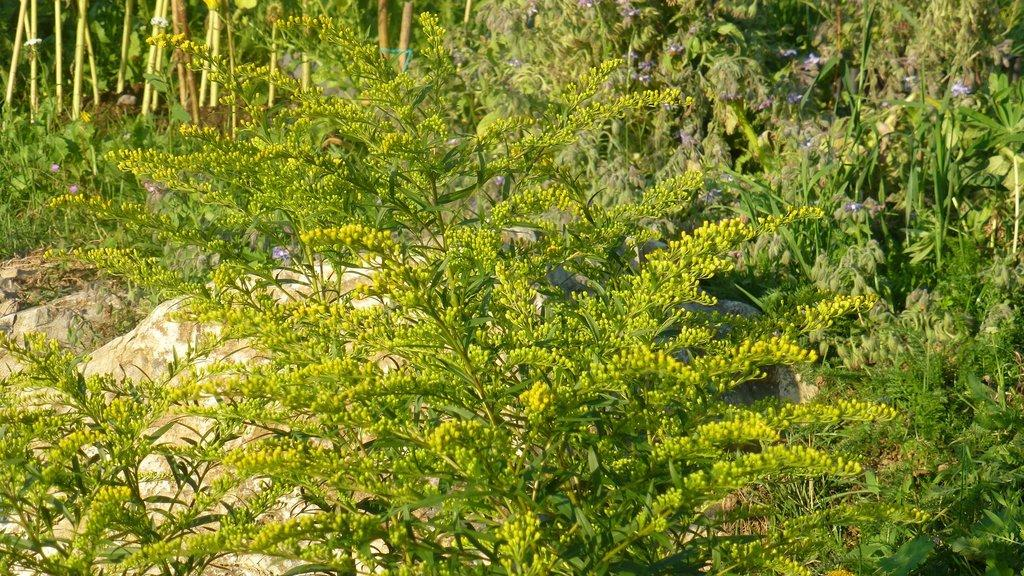What type of flowers are on the trees in the image? The trees in the image have yellow flowers. What can be seen on the ground in the background of the image? There are plants and trees on the ground in the background of the image. What type of hook can be seen attached to the tank in the image? There is no hook or tank present in the image; it features trees with yellow flowers and plants and trees on the ground. 